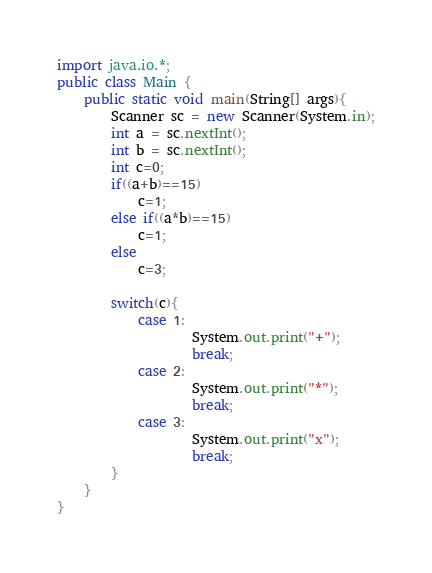Convert code to text. <code><loc_0><loc_0><loc_500><loc_500><_Java_>import java.io.*;
public class Main {
	public static void main(String[] args){
		Scanner sc = new Scanner(System.in);
		int a = sc.nextInt();
	    int b = sc.nextInt();
		int c=0;
		if((a+b)==15)
			c=1;
		else if((a*b)==15)
			c=1;
		else
			c=3;
		
		switch(c){
			case 1:
					System.out.print("+");	
					break;
			case 2:
					System.out.print("*");	
					break;
			case 3:
					System.out.print("x");	
					break;
		}
	}
}</code> 